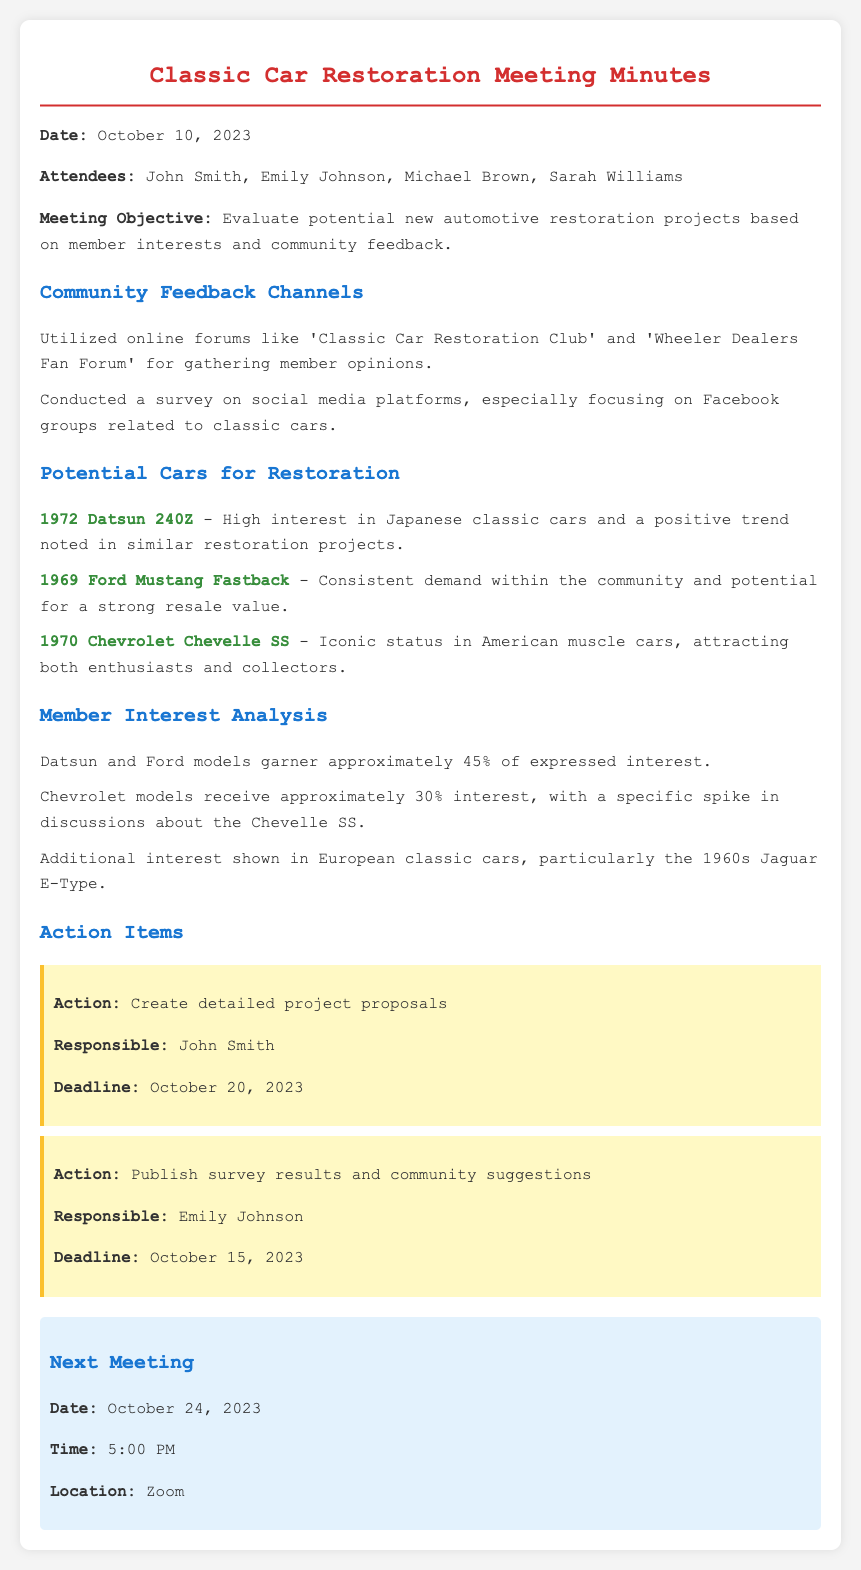what date was the meeting held? The document states that the meeting took place on October 10, 2023.
Answer: October 10, 2023 who is responsible for creating detailed project proposals? The minutes specify that John Smith is tasked with creating the proposals.
Answer: John Smith what percentage of interest is shown for Datsun and Ford models? The document indicates that Datsun and Ford models garner approximately 45% of expressed interest.
Answer: 45% which car model received a significant spike in discussions? The minutes mention that there is a specific spike in discussions about the Chevrolet Chevelle SS.
Answer: Chevrolet Chevelle SS when is the next meeting scheduled? According to the document, the next meeting is scheduled for October 24, 2023.
Answer: October 24, 2023 what community feedback channels were utilized? The document lists online forums and social media surveys as feedback channels.
Answer: Online forums and social media surveys which classic car model is noted for its potential strong resale value? The meeting minutes highlight the 1969 Ford Mustang Fastback as having potential for strong resale value.
Answer: 1969 Ford Mustang Fastback how many members attended the meeting? The document lists four attendees: John Smith, Emily Johnson, Michael Brown, and Sarah Williams, which indicates there were four members present.
Answer: four 